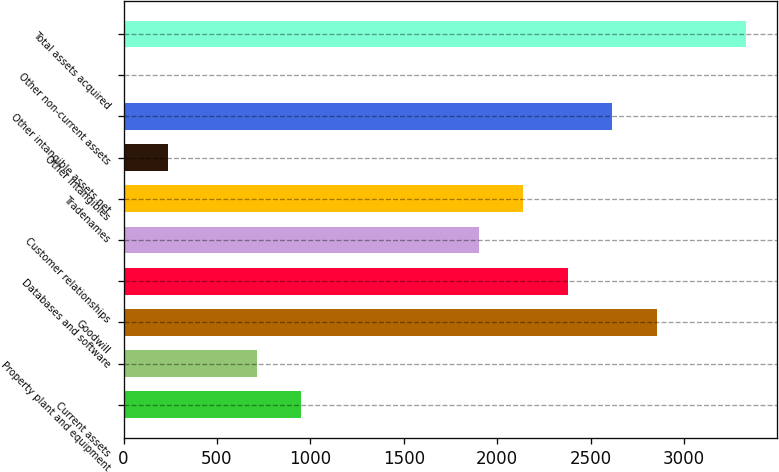Convert chart. <chart><loc_0><loc_0><loc_500><loc_500><bar_chart><fcel>Current assets<fcel>Property plant and equipment<fcel>Goodwill<fcel>Databases and software<fcel>Customer relationships<fcel>Tradenames<fcel>Other intangibles<fcel>Other intangible assets net<fcel>Other non-current assets<fcel>Total assets acquired<nl><fcel>951.8<fcel>714.1<fcel>2853.4<fcel>2378<fcel>1902.6<fcel>2140.3<fcel>238.7<fcel>2615.7<fcel>1<fcel>3328.8<nl></chart> 